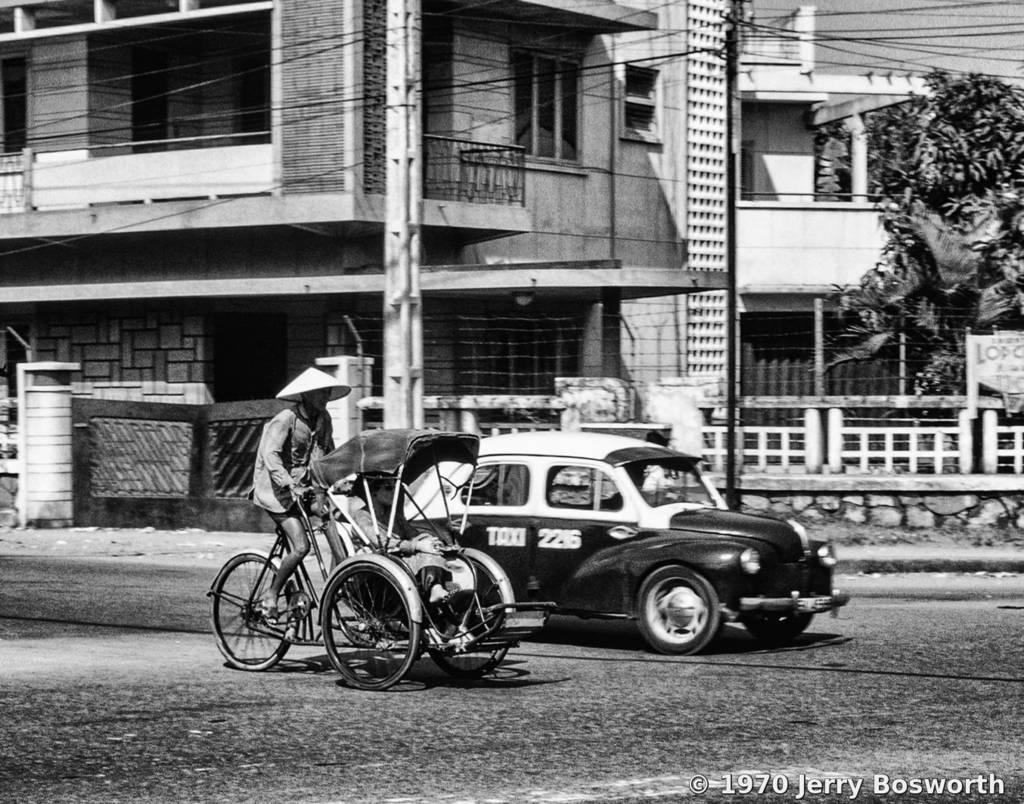What is the color scheme of the image? The image is in black and white. What type of structure can be seen in the image? There is a building with a fence and windows in the image. What is the entrance to the building like? There is a gate visible in the image. What is happening on the road in the image? Vehicles are present on the road in the image. What activity is a person engaged in within the image? A man is riding a bicycle in the image. What can be seen in the distance in the image? Trees are visible in the distance in the image. What type of baseball game is being played in the image? There is no baseball game present in the image. What suggestion does the man on the bicycle have for the viewer? The man on the bicycle is not making any suggestions to the viewer in the image. 